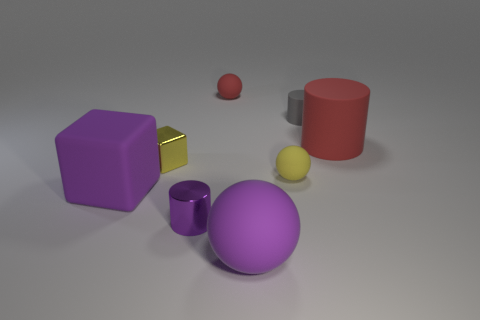Does the red sphere have the same material as the yellow block?
Offer a terse response. No. Are there more yellow rubber objects that are behind the tiny purple object than large green rubber cylinders?
Offer a very short reply. Yes. What material is the small cylinder left of the red object that is behind the object that is right of the gray cylinder?
Provide a short and direct response. Metal. How many things are cyan objects or red matte objects that are to the right of the big ball?
Your response must be concise. 1. There is a cylinder in front of the big red matte cylinder; is it the same color as the big cube?
Make the answer very short. Yes. Is the number of big matte things to the left of the large purple ball greater than the number of gray rubber things in front of the tiny purple object?
Provide a succinct answer. Yes. Is there anything else of the same color as the big matte cylinder?
Your response must be concise. Yes. How many things are either big brown cylinders or gray things?
Offer a terse response. 1. There is a cylinder left of the purple sphere; is its size the same as the big purple matte sphere?
Offer a very short reply. No. How many other objects are there of the same size as the gray matte object?
Give a very brief answer. 4. 